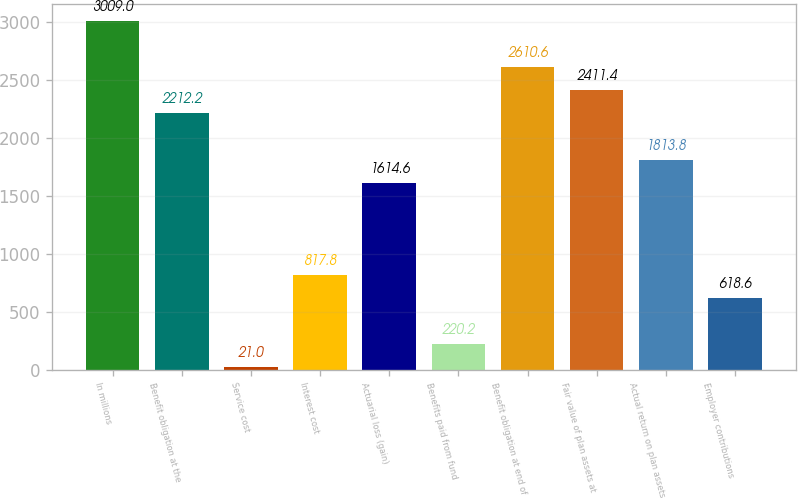<chart> <loc_0><loc_0><loc_500><loc_500><bar_chart><fcel>In millions<fcel>Benefit obligation at the<fcel>Service cost<fcel>Interest cost<fcel>Actuarial loss (gain)<fcel>Benefits paid from fund<fcel>Benefit obligation at end of<fcel>Fair value of plan assets at<fcel>Actual return on plan assets<fcel>Employer contributions<nl><fcel>3009<fcel>2212.2<fcel>21<fcel>817.8<fcel>1614.6<fcel>220.2<fcel>2610.6<fcel>2411.4<fcel>1813.8<fcel>618.6<nl></chart> 